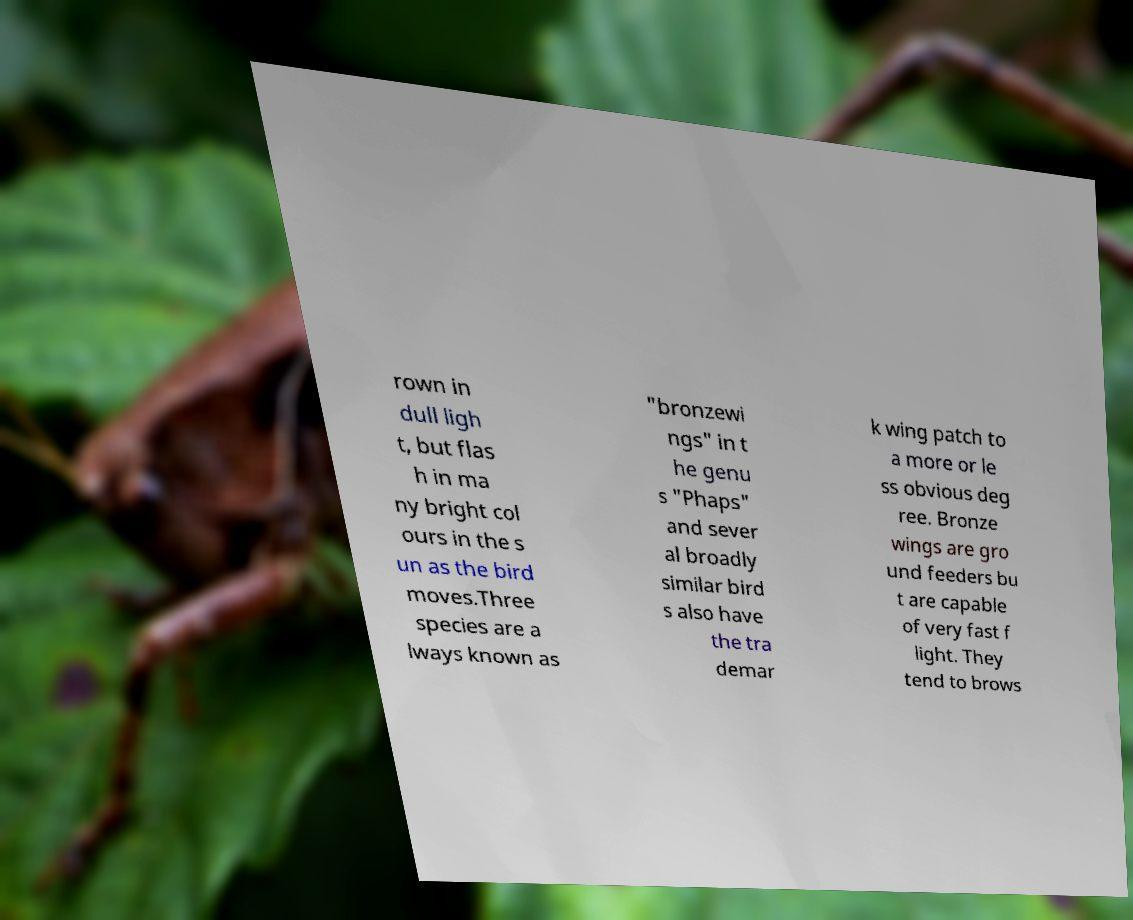Can you accurately transcribe the text from the provided image for me? rown in dull ligh t, but flas h in ma ny bright col ours in the s un as the bird moves.Three species are a lways known as "bronzewi ngs" in t he genu s "Phaps" and sever al broadly similar bird s also have the tra demar k wing patch to a more or le ss obvious deg ree. Bronze wings are gro und feeders bu t are capable of very fast f light. They tend to brows 